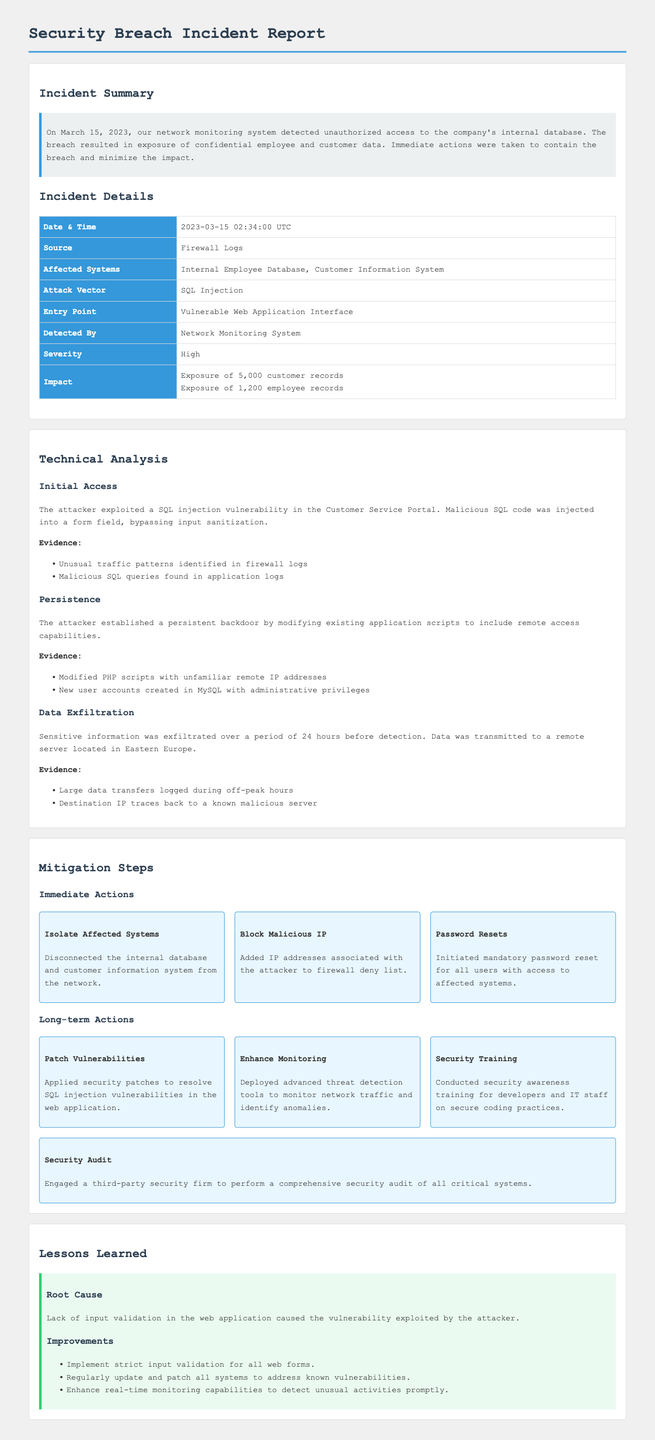What date was the security breach detected? The breach was detected on March 15, 2023, as mentioned in the incident summary.
Answer: March 15, 2023 What was the attack vector used in the incident? The document states that the attack vector was SQL injection.
Answer: SQL Injection How many customer records were exposed during the breach? The impact section specifies the exposure of 5,000 customer records.
Answer: 5,000 What immediate action involved disconnecting systems? The action to disconnect the internal database and customer information system from the network is stated under immediate actions.
Answer: Isolate Affected Systems What are the long-term actions taken post-incident? The document lists long-term actions including patching vulnerabilities, enhancing monitoring, security training, and performing a security audit.
Answer: Patch Vulnerabilities, Enhance Monitoring, Security Training, Security Audit What was identified as the root cause of the incident? The root cause of the incident was a lack of input validation in the web application.
Answer: Lack of input validation How many employee records were compromised? The document notes that 1,200 employee records were exposed.
Answer: 1,200 What types of files were modified by the attacker for persistence? The attacker modified existing PHP scripts for establishing persistence, as mentioned in the technical analysis section.
Answer: PHP scripts Where was the remote server located that received the exfiltrated data? The document indicates that the data was transmitted to a remote server located in Eastern Europe.
Answer: Eastern Europe 